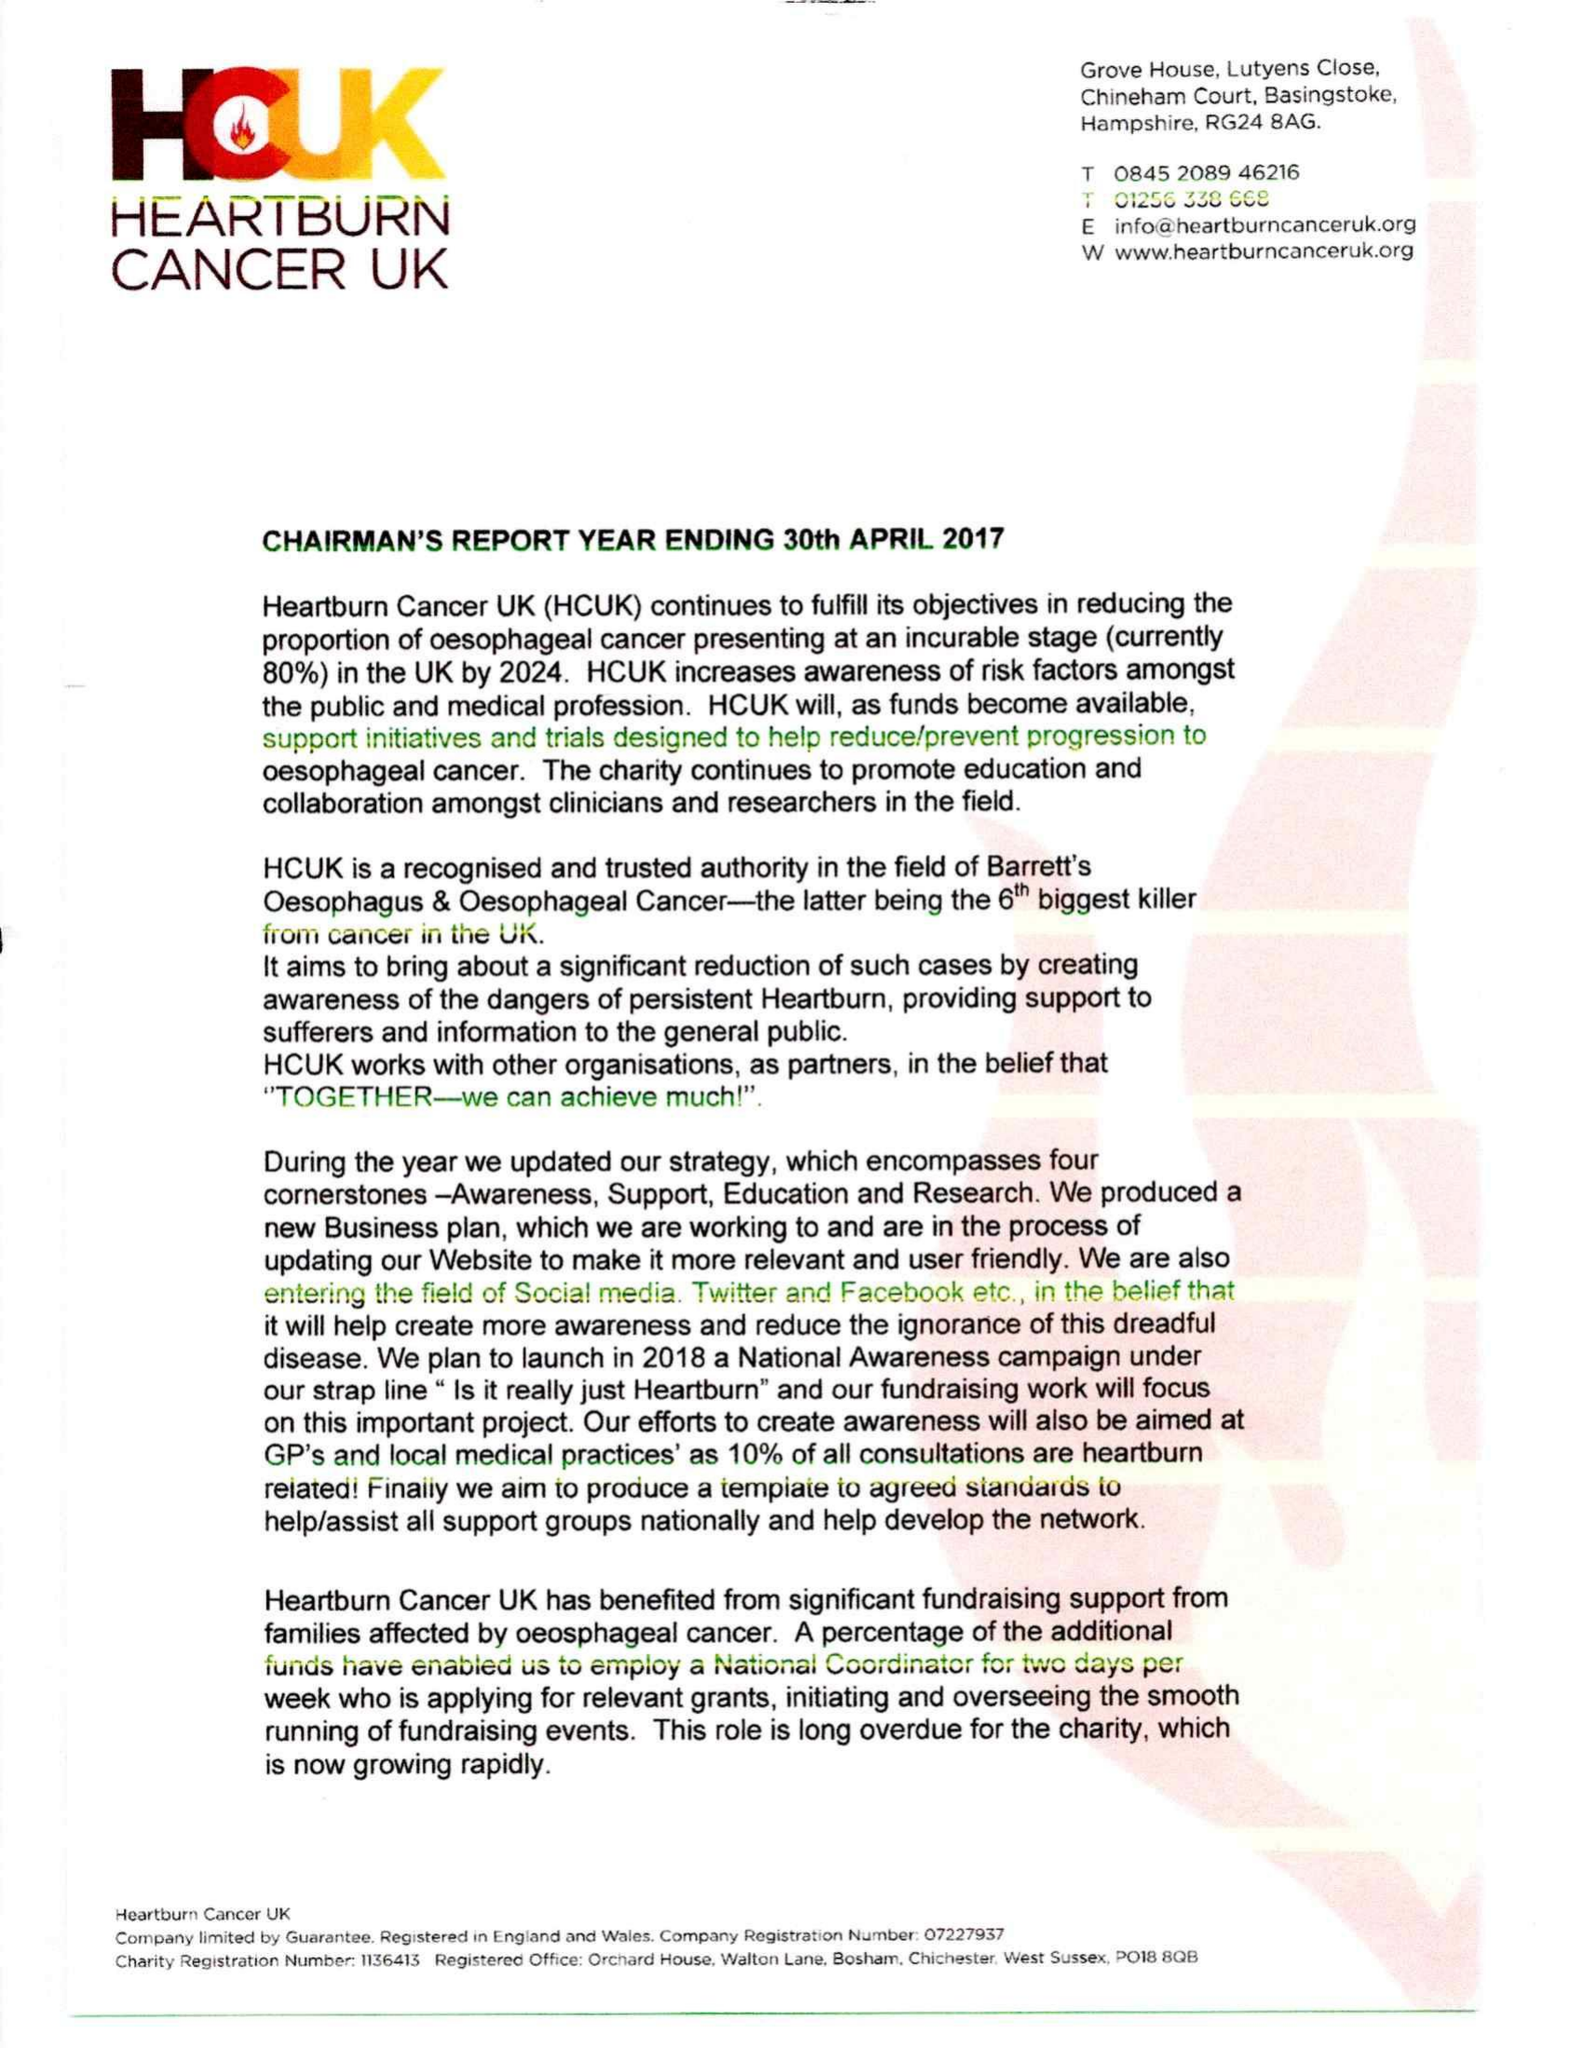What is the value for the charity_number?
Answer the question using a single word or phrase. 1136413 